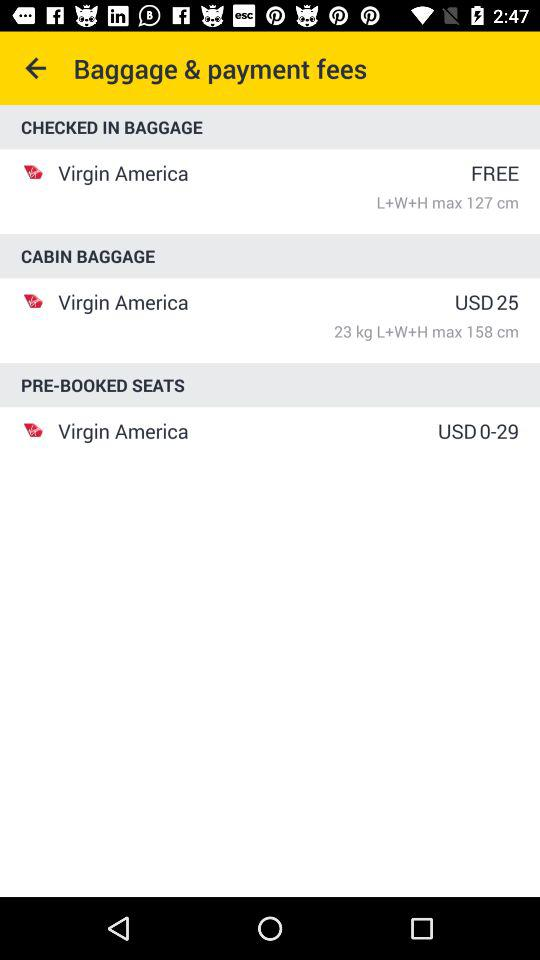What is the baggage payment fee? The baggage payment fee is free. 